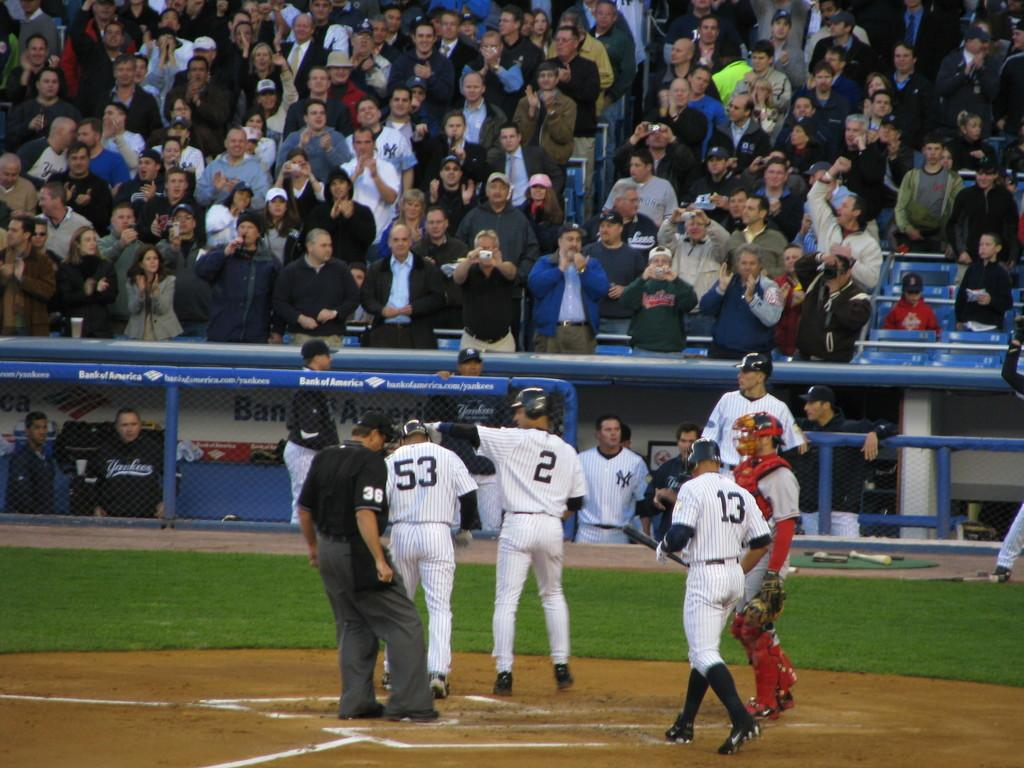<image>
Describe the image concisely. some players with different numbers including the number 2 